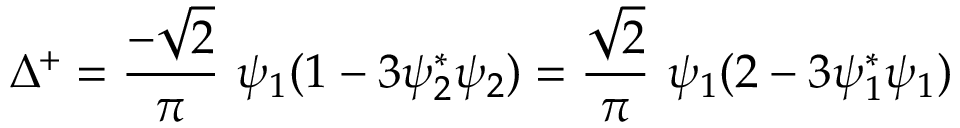<formula> <loc_0><loc_0><loc_500><loc_500>\Delta ^ { + } = \frac { - \sqrt { 2 } } { \pi } \psi _ { 1 } ( 1 - 3 \psi _ { 2 } ^ { * } \psi _ { 2 } ) = \frac { \sqrt { 2 } } { \pi } \psi _ { 1 } ( 2 - 3 \psi _ { 1 } ^ { * } \psi _ { 1 } )</formula> 